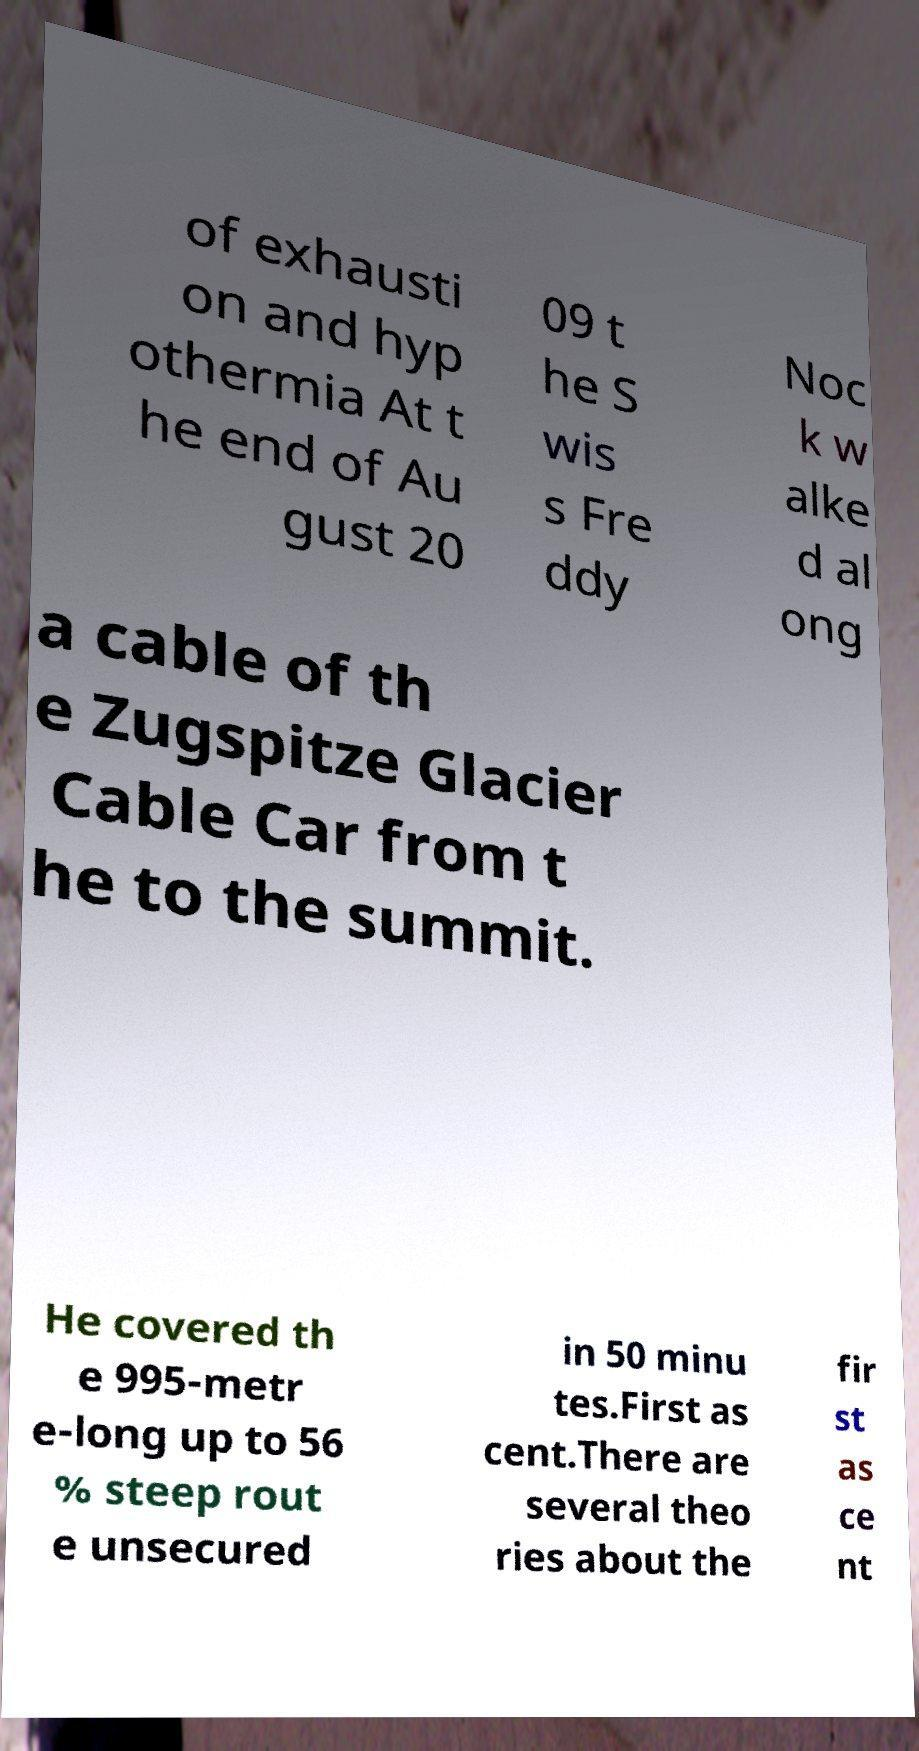For documentation purposes, I need the text within this image transcribed. Could you provide that? of exhausti on and hyp othermia At t he end of Au gust 20 09 t he S wis s Fre ddy Noc k w alke d al ong a cable of th e Zugspitze Glacier Cable Car from t he to the summit. He covered th e 995-metr e-long up to 56 % steep rout e unsecured in 50 minu tes.First as cent.There are several theo ries about the fir st as ce nt 